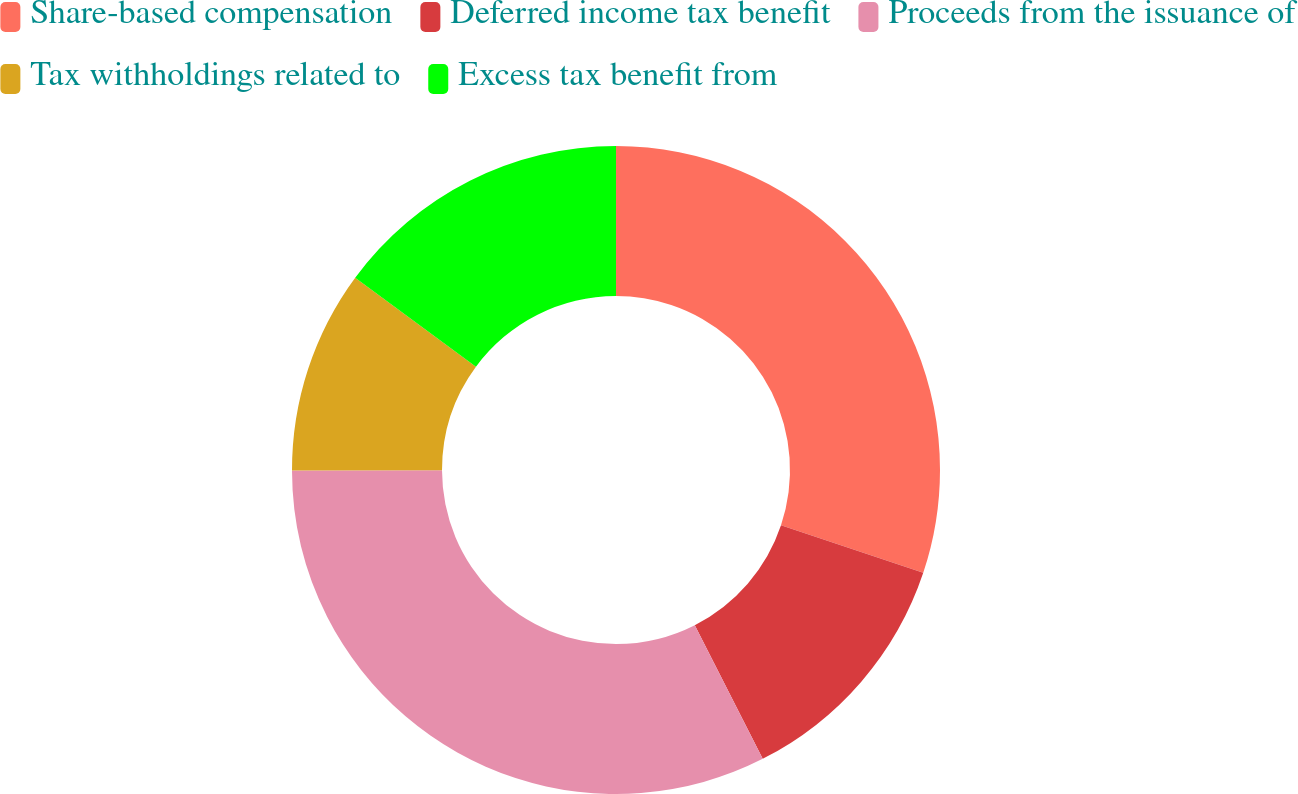Convert chart. <chart><loc_0><loc_0><loc_500><loc_500><pie_chart><fcel>Share-based compensation<fcel>Deferred income tax benefit<fcel>Proceeds from the issuance of<fcel>Tax withholdings related to<fcel>Excess tax benefit from<nl><fcel>30.14%<fcel>12.38%<fcel>32.45%<fcel>10.14%<fcel>14.89%<nl></chart> 